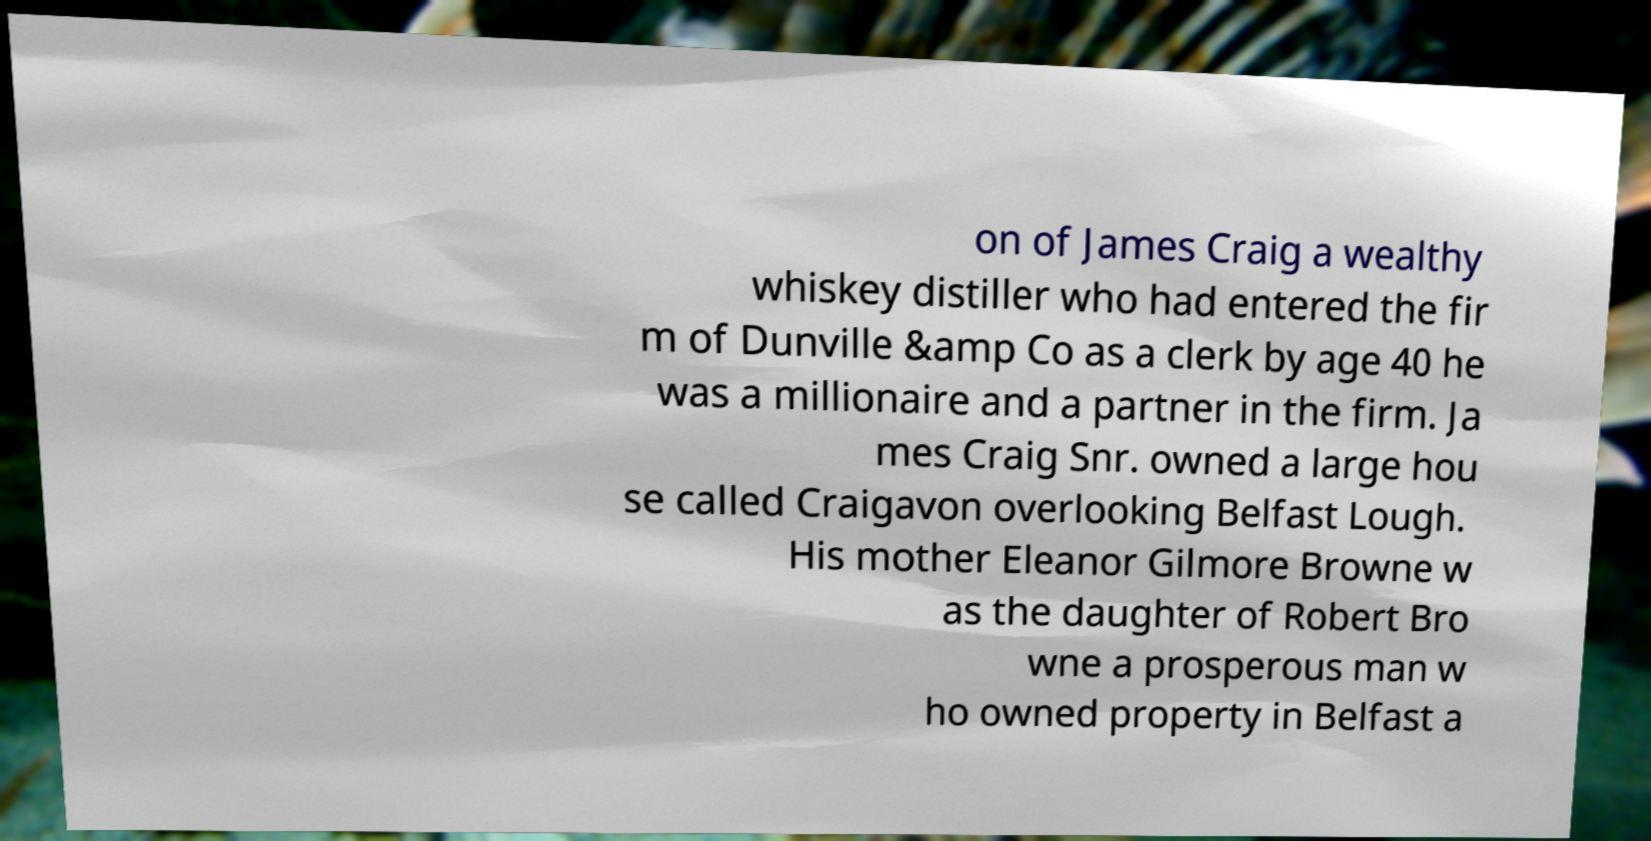There's text embedded in this image that I need extracted. Can you transcribe it verbatim? on of James Craig a wealthy whiskey distiller who had entered the fir m of Dunville &amp Co as a clerk by age 40 he was a millionaire and a partner in the firm. Ja mes Craig Snr. owned a large hou se called Craigavon overlooking Belfast Lough. His mother Eleanor Gilmore Browne w as the daughter of Robert Bro wne a prosperous man w ho owned property in Belfast a 